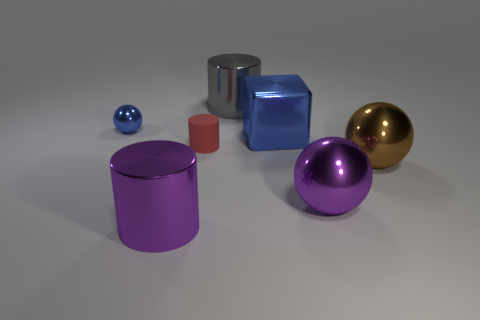There is a metal ball behind the brown ball; is its color the same as the big cylinder that is behind the small blue metal sphere?
Your answer should be compact. No. The large shiny object that is in front of the tiny blue object and behind the brown thing is what color?
Give a very brief answer. Blue. Are the red object and the blue cube made of the same material?
Make the answer very short. No. How many tiny objects are either blue cubes or brown metal spheres?
Make the answer very short. 0. Are there any other things that have the same shape as the large brown metal object?
Give a very brief answer. Yes. Is there any other thing that is the same size as the brown ball?
Provide a succinct answer. Yes. What is the color of the other small thing that is made of the same material as the gray object?
Give a very brief answer. Blue. What color is the small thing that is behind the large blue metallic block?
Provide a succinct answer. Blue. What number of other large metallic cubes have the same color as the large cube?
Your answer should be very brief. 0. Is the number of brown metal spheres that are in front of the purple sphere less than the number of big purple metal balls that are behind the big gray cylinder?
Offer a terse response. No. 